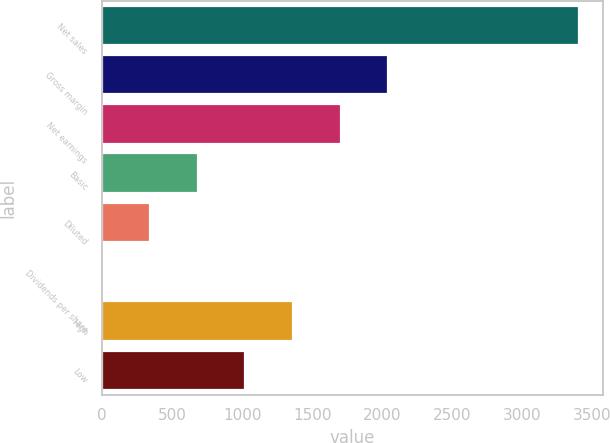Convert chart. <chart><loc_0><loc_0><loc_500><loc_500><bar_chart><fcel>Net sales<fcel>Gross margin<fcel>Net earnings<fcel>Basic<fcel>Diluted<fcel>Dividends per share<fcel>High<fcel>Low<nl><fcel>3405.6<fcel>2043.51<fcel>1702.99<fcel>681.43<fcel>340.91<fcel>0.39<fcel>1362.47<fcel>1021.95<nl></chart> 